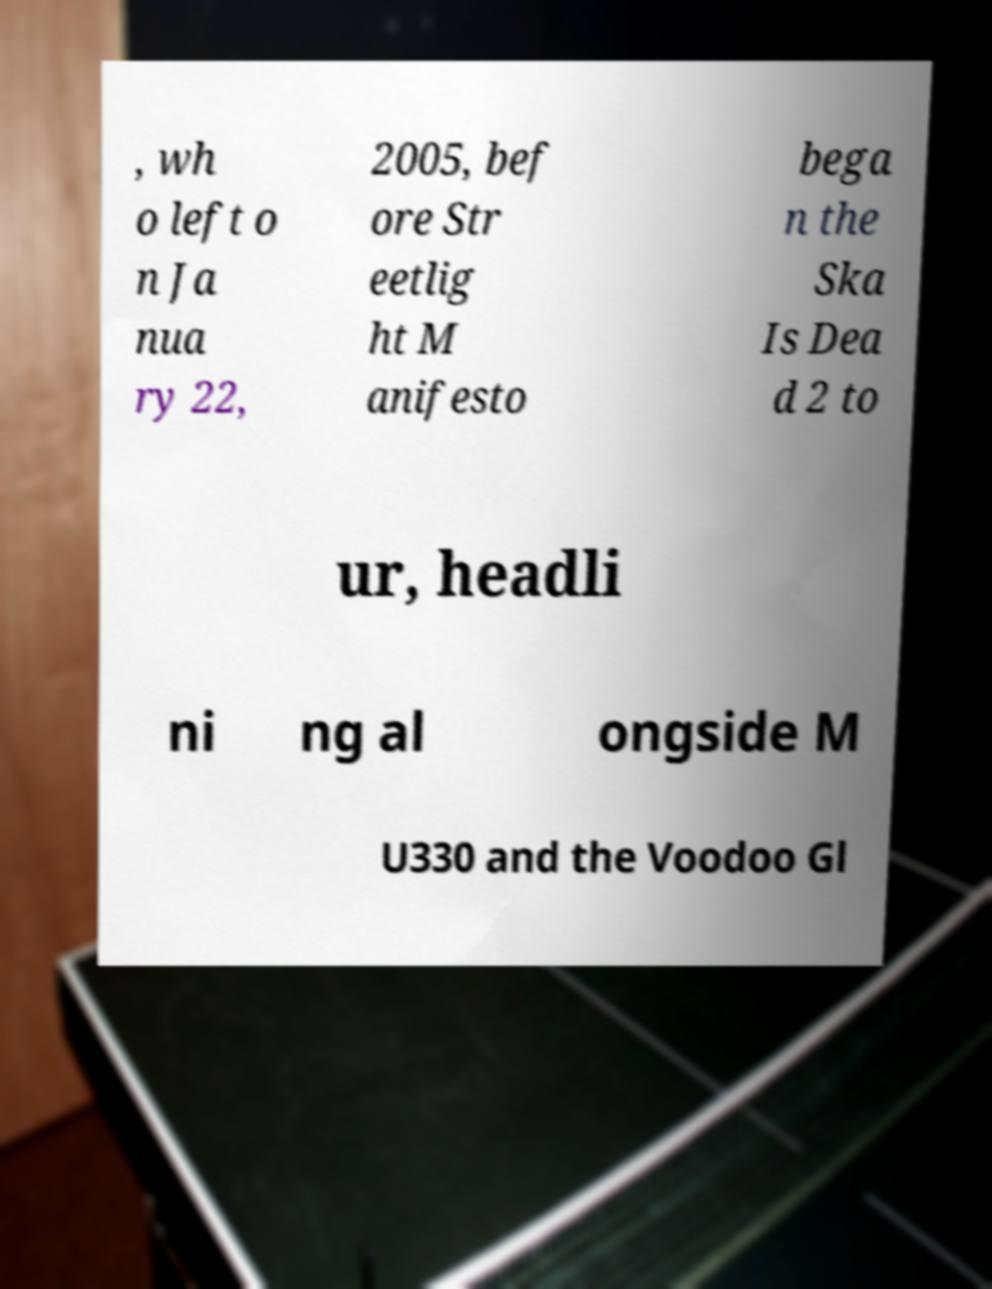There's text embedded in this image that I need extracted. Can you transcribe it verbatim? , wh o left o n Ja nua ry 22, 2005, bef ore Str eetlig ht M anifesto bega n the Ska Is Dea d 2 to ur, headli ni ng al ongside M U330 and the Voodoo Gl 